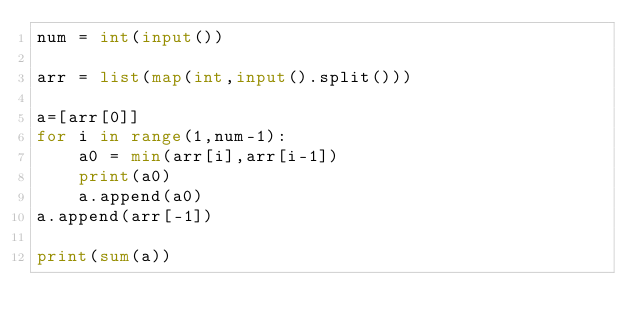<code> <loc_0><loc_0><loc_500><loc_500><_Python_>num = int(input())

arr = list(map(int,input().split()))

a=[arr[0]]
for i in range(1,num-1):
    a0 = min(arr[i],arr[i-1])
    print(a0)
    a.append(a0)
a.append(arr[-1])

print(sum(a))</code> 